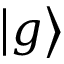Convert formula to latex. <formula><loc_0><loc_0><loc_500><loc_500>\left | g \right \rangle</formula> 